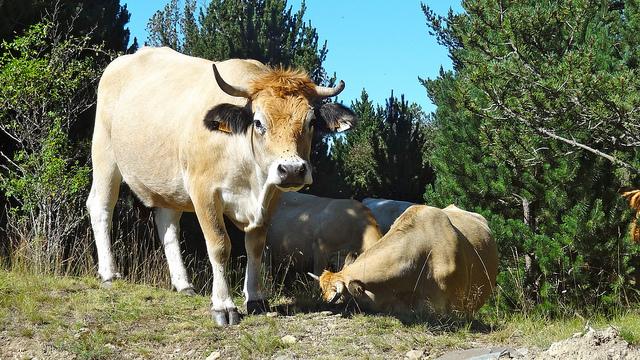What are the cows doing?
Write a very short answer. Resting. Are any of the animals eating?
Write a very short answer. No. Is this cow tagged?
Write a very short answer. Yes. Are these cows undernourished?
Give a very brief answer. No. What kind of animal is standing?
Short answer required. Cow. What color is the cow?
Quick response, please. Brown. What is the small white animal?
Be succinct. Cow. What type of animal is laying down?
Keep it brief. Cow. 